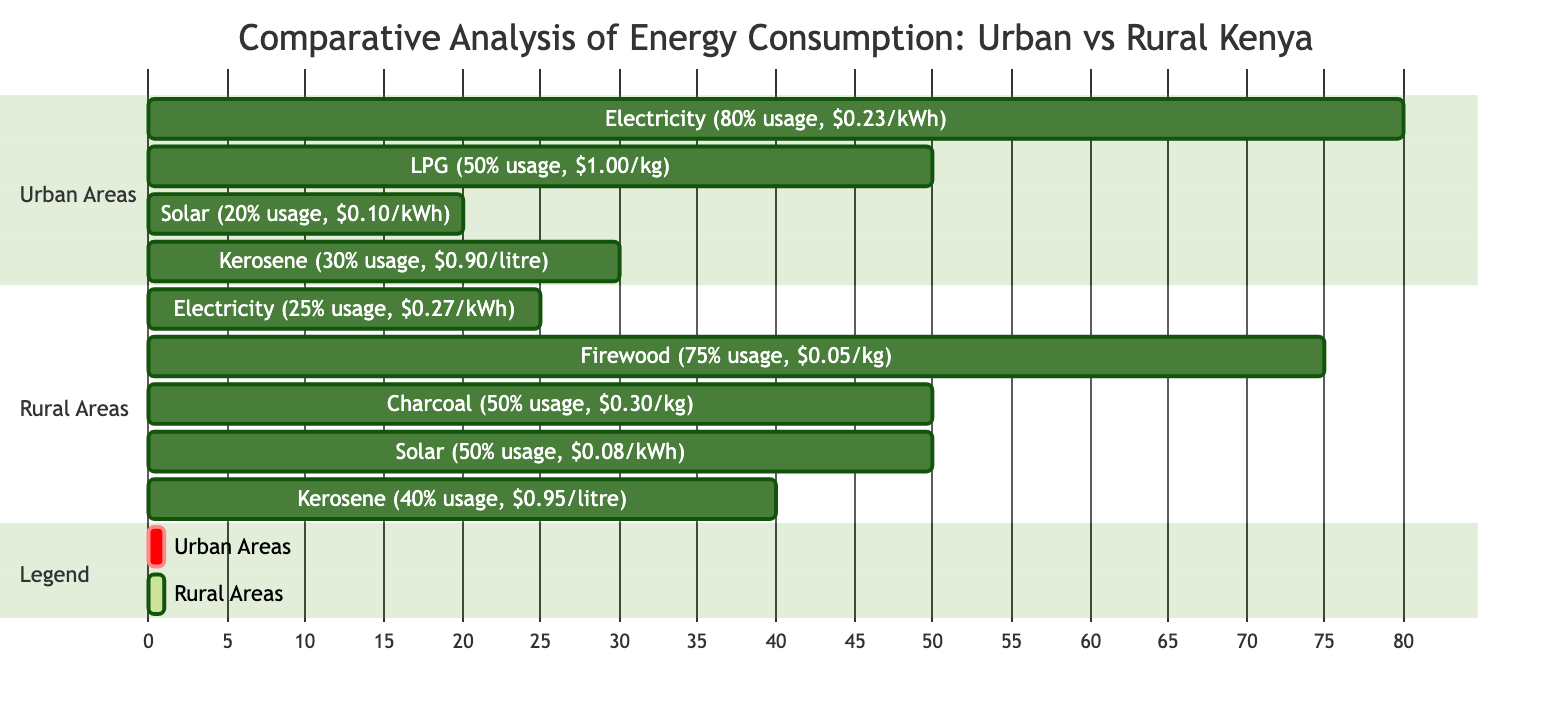What percentage of energy consumption in urban areas is from electricity? The diagram states that electricity usage in urban areas is at 80%, as indicated in the data in the respective section.
Answer: 80% What is the cost per kilowatt-hour for solar energy in rural areas? According to the diagram, the cost for solar energy in rural areas is stated as $0.08 per kWh, which is specified in the section detailing energy usage for rural areas.
Answer: $0.08 Which energy source has the highest usage rate in rural areas? Penetrating the rural area section, firewood is indicated with a usage rate of 75%, which is the highest compared to the other listed sources.
Answer: Firewood How does the cost of kerosene in urban areas compare to that in rural areas? The cost of kerosene in urban areas is $0.90 per liter while in rural areas it is $0.95 per liter. Thus, urban kerosene is cheaper than rural.
Answer: Urban is cheaper What is the total percentage of renewable energy sources utilized in urban areas? Renewable sources in urban areas include solar (20%). No other renewable sources are indicated, leading to a total of 20% for urban areas.
Answer: 20% Is the energy usage of kerosene higher in urban areas or rural areas? The diagram shows that kerosene usage in urban areas is 30% and in rural areas is 40%. Hence, it is higher in rural areas.
Answer: Rural areas What is the combined percentage of electricity and solar energy consumption in urban areas? For urban areas, electricity (80%) and solar (20%) should be added together, resulting in a total of 100% for those renewable-related sources within this setting.
Answer: 100% Which category in the diagram signifies energy sources for rural areas? The section labeled "Rural Areas" in the diagram explicitly outlines all the energy sources used in those settings, providing clarity on the sources used.
Answer: Rural Areas 